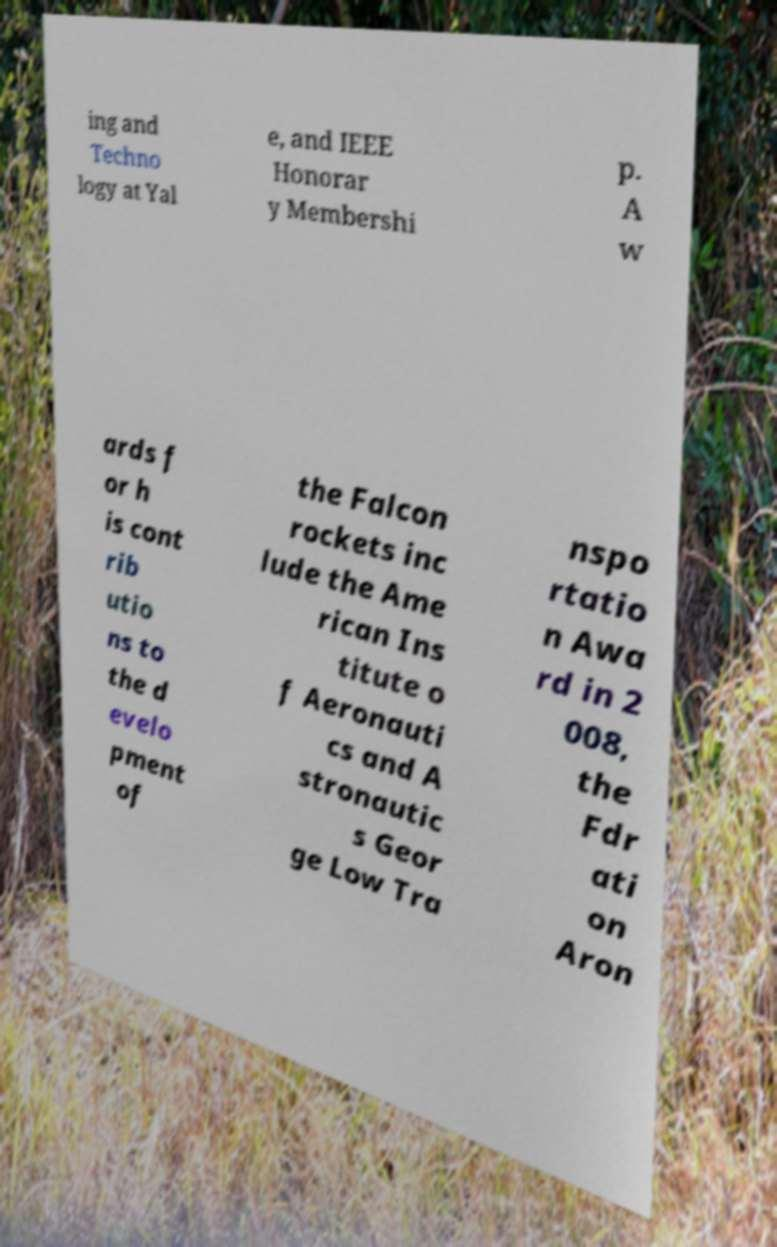What messages or text are displayed in this image? I need them in a readable, typed format. ing and Techno logy at Yal e, and IEEE Honorar y Membershi p. A w ards f or h is cont rib utio ns to the d evelo pment of the Falcon rockets inc lude the Ame rican Ins titute o f Aeronauti cs and A stronautic s Geor ge Low Tra nspo rtatio n Awa rd in 2 008, the Fdr ati on Aron 